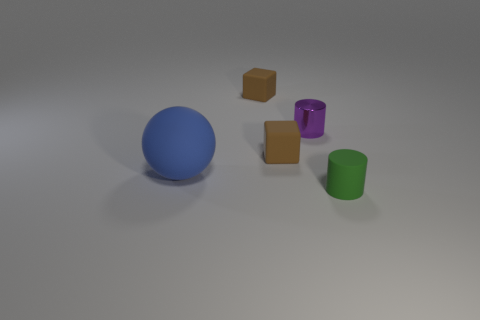What number of other objects are the same size as the purple cylinder?
Give a very brief answer. 3. Are there an equal number of tiny shiny cylinders to the left of the tiny green cylinder and large blue rubber balls?
Offer a very short reply. Yes. Do the rubber block that is behind the small metallic thing and the small rubber cube that is in front of the purple cylinder have the same color?
Your response must be concise. Yes. There is a small thing that is on the left side of the small metallic cylinder and in front of the purple cylinder; what is its material?
Your answer should be very brief. Rubber. The ball has what color?
Provide a short and direct response. Blue. What number of other objects are the same shape as the large thing?
Give a very brief answer. 0. Are there the same number of small rubber objects in front of the purple metal thing and rubber blocks that are behind the green thing?
Your answer should be very brief. Yes. What is the material of the purple object?
Offer a terse response. Metal. What material is the tiny cylinder behind the large blue sphere?
Ensure brevity in your answer.  Metal. Is there any other thing that has the same material as the large blue sphere?
Keep it short and to the point. Yes. 